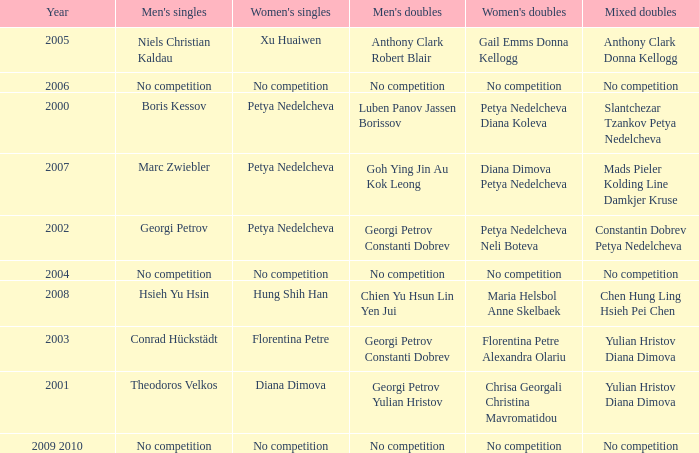What is the year when Conrad Hückstädt won Men's Single? 2003.0. 